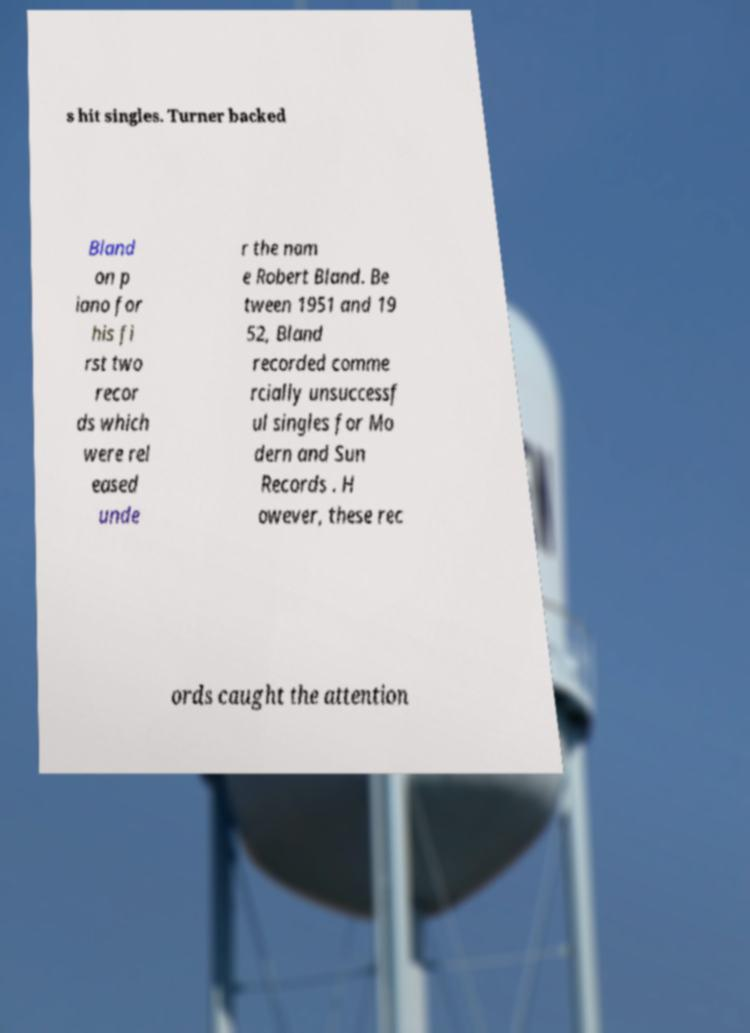Please identify and transcribe the text found in this image. s hit singles. Turner backed Bland on p iano for his fi rst two recor ds which were rel eased unde r the nam e Robert Bland. Be tween 1951 and 19 52, Bland recorded comme rcially unsuccessf ul singles for Mo dern and Sun Records . H owever, these rec ords caught the attention 